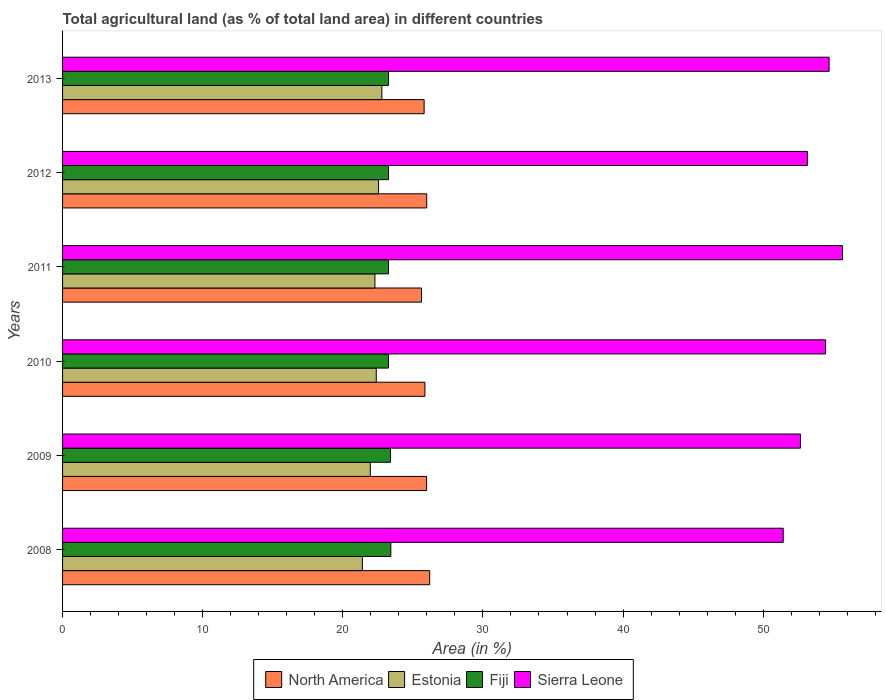How many groups of bars are there?
Offer a very short reply. 6. Are the number of bars per tick equal to the number of legend labels?
Offer a very short reply. Yes. Are the number of bars on each tick of the Y-axis equal?
Offer a very short reply. Yes. How many bars are there on the 4th tick from the top?
Offer a terse response. 4. What is the percentage of agricultural land in North America in 2008?
Give a very brief answer. 26.2. Across all years, what is the maximum percentage of agricultural land in Estonia?
Keep it short and to the point. 22.79. Across all years, what is the minimum percentage of agricultural land in Estonia?
Your answer should be compact. 21.4. In which year was the percentage of agricultural land in Estonia minimum?
Give a very brief answer. 2008. What is the total percentage of agricultural land in Fiji in the graph?
Your response must be concise. 139.88. What is the difference between the percentage of agricultural land in Fiji in 2008 and that in 2013?
Provide a succinct answer. 0.16. What is the difference between the percentage of agricultural land in Estonia in 2010 and the percentage of agricultural land in Fiji in 2011?
Keep it short and to the point. -0.87. What is the average percentage of agricultural land in Sierra Leone per year?
Make the answer very short. 53.68. In the year 2012, what is the difference between the percentage of agricultural land in Sierra Leone and percentage of agricultural land in Fiji?
Your answer should be compact. 29.89. What is the ratio of the percentage of agricultural land in Fiji in 2010 to that in 2012?
Your answer should be compact. 1. Is the percentage of agricultural land in Fiji in 2009 less than that in 2010?
Keep it short and to the point. No. Is the difference between the percentage of agricultural land in Sierra Leone in 2011 and 2013 greater than the difference between the percentage of agricultural land in Fiji in 2011 and 2013?
Your response must be concise. Yes. What is the difference between the highest and the second highest percentage of agricultural land in Sierra Leone?
Give a very brief answer. 0.96. What is the difference between the highest and the lowest percentage of agricultural land in North America?
Your answer should be compact. 0.58. What does the 3rd bar from the top in 2008 represents?
Your response must be concise. Estonia. What does the 4th bar from the bottom in 2013 represents?
Your answer should be very brief. Sierra Leone. Is it the case that in every year, the sum of the percentage of agricultural land in Estonia and percentage of agricultural land in Fiji is greater than the percentage of agricultural land in Sierra Leone?
Offer a very short reply. No. How many years are there in the graph?
Make the answer very short. 6. What is the difference between two consecutive major ticks on the X-axis?
Give a very brief answer. 10. Are the values on the major ticks of X-axis written in scientific E-notation?
Provide a short and direct response. No. Does the graph contain any zero values?
Ensure brevity in your answer.  No. Does the graph contain grids?
Offer a terse response. No. Where does the legend appear in the graph?
Offer a terse response. Bottom center. How many legend labels are there?
Give a very brief answer. 4. How are the legend labels stacked?
Offer a very short reply. Horizontal. What is the title of the graph?
Make the answer very short. Total agricultural land (as % of total land area) in different countries. What is the label or title of the X-axis?
Your response must be concise. Area (in %). What is the Area (in %) of North America in 2008?
Give a very brief answer. 26.2. What is the Area (in %) of Estonia in 2008?
Provide a succinct answer. 21.4. What is the Area (in %) in Fiji in 2008?
Keep it short and to the point. 23.43. What is the Area (in %) in Sierra Leone in 2008?
Your answer should be very brief. 51.43. What is the Area (in %) in North America in 2009?
Make the answer very short. 25.98. What is the Area (in %) in Estonia in 2009?
Your answer should be very brief. 21.96. What is the Area (in %) of Fiji in 2009?
Your response must be concise. 23.4. What is the Area (in %) of Sierra Leone in 2009?
Your answer should be very brief. 52.66. What is the Area (in %) in North America in 2010?
Your response must be concise. 25.86. What is the Area (in %) in Estonia in 2010?
Give a very brief answer. 22.39. What is the Area (in %) in Fiji in 2010?
Make the answer very short. 23.26. What is the Area (in %) in Sierra Leone in 2010?
Keep it short and to the point. 54.45. What is the Area (in %) of North America in 2011?
Give a very brief answer. 25.62. What is the Area (in %) in Estonia in 2011?
Make the answer very short. 22.29. What is the Area (in %) of Fiji in 2011?
Offer a very short reply. 23.26. What is the Area (in %) in Sierra Leone in 2011?
Your response must be concise. 55.66. What is the Area (in %) in North America in 2012?
Provide a succinct answer. 25.99. What is the Area (in %) of Estonia in 2012?
Your answer should be very brief. 22.55. What is the Area (in %) of Fiji in 2012?
Your response must be concise. 23.26. What is the Area (in %) in Sierra Leone in 2012?
Offer a very short reply. 53.15. What is the Area (in %) of North America in 2013?
Your answer should be very brief. 25.8. What is the Area (in %) of Estonia in 2013?
Make the answer very short. 22.79. What is the Area (in %) of Fiji in 2013?
Offer a terse response. 23.26. What is the Area (in %) in Sierra Leone in 2013?
Offer a terse response. 54.71. Across all years, what is the maximum Area (in %) in North America?
Make the answer very short. 26.2. Across all years, what is the maximum Area (in %) in Estonia?
Ensure brevity in your answer.  22.79. Across all years, what is the maximum Area (in %) of Fiji?
Make the answer very short. 23.43. Across all years, what is the maximum Area (in %) of Sierra Leone?
Your response must be concise. 55.66. Across all years, what is the minimum Area (in %) in North America?
Your answer should be very brief. 25.62. Across all years, what is the minimum Area (in %) in Estonia?
Offer a very short reply. 21.4. Across all years, what is the minimum Area (in %) in Fiji?
Your answer should be very brief. 23.26. Across all years, what is the minimum Area (in %) of Sierra Leone?
Provide a succinct answer. 51.43. What is the total Area (in %) in North America in the graph?
Offer a very short reply. 155.45. What is the total Area (in %) in Estonia in the graph?
Offer a terse response. 133.38. What is the total Area (in %) in Fiji in the graph?
Make the answer very short. 139.88. What is the total Area (in %) in Sierra Leone in the graph?
Offer a very short reply. 322.06. What is the difference between the Area (in %) of North America in 2008 and that in 2009?
Your response must be concise. 0.22. What is the difference between the Area (in %) in Estonia in 2008 and that in 2009?
Keep it short and to the point. -0.57. What is the difference between the Area (in %) of Fiji in 2008 and that in 2009?
Offer a terse response. 0.02. What is the difference between the Area (in %) of Sierra Leone in 2008 and that in 2009?
Your response must be concise. -1.23. What is the difference between the Area (in %) in North America in 2008 and that in 2010?
Offer a terse response. 0.34. What is the difference between the Area (in %) in Estonia in 2008 and that in 2010?
Your answer should be compact. -0.99. What is the difference between the Area (in %) of Fiji in 2008 and that in 2010?
Ensure brevity in your answer.  0.16. What is the difference between the Area (in %) of Sierra Leone in 2008 and that in 2010?
Give a very brief answer. -3.02. What is the difference between the Area (in %) of North America in 2008 and that in 2011?
Give a very brief answer. 0.58. What is the difference between the Area (in %) in Estonia in 2008 and that in 2011?
Ensure brevity in your answer.  -0.9. What is the difference between the Area (in %) of Fiji in 2008 and that in 2011?
Keep it short and to the point. 0.16. What is the difference between the Area (in %) of Sierra Leone in 2008 and that in 2011?
Give a very brief answer. -4.23. What is the difference between the Area (in %) in North America in 2008 and that in 2012?
Provide a short and direct response. 0.21. What is the difference between the Area (in %) of Estonia in 2008 and that in 2012?
Offer a very short reply. -1.16. What is the difference between the Area (in %) in Fiji in 2008 and that in 2012?
Give a very brief answer. 0.16. What is the difference between the Area (in %) in Sierra Leone in 2008 and that in 2012?
Provide a short and direct response. -1.72. What is the difference between the Area (in %) of North America in 2008 and that in 2013?
Provide a succinct answer. 0.4. What is the difference between the Area (in %) of Estonia in 2008 and that in 2013?
Offer a very short reply. -1.39. What is the difference between the Area (in %) of Fiji in 2008 and that in 2013?
Keep it short and to the point. 0.16. What is the difference between the Area (in %) in Sierra Leone in 2008 and that in 2013?
Provide a succinct answer. -3.28. What is the difference between the Area (in %) in North America in 2009 and that in 2010?
Your answer should be very brief. 0.12. What is the difference between the Area (in %) in Estonia in 2009 and that in 2010?
Give a very brief answer. -0.42. What is the difference between the Area (in %) of Fiji in 2009 and that in 2010?
Give a very brief answer. 0.14. What is the difference between the Area (in %) of Sierra Leone in 2009 and that in 2010?
Offer a terse response. -1.79. What is the difference between the Area (in %) in North America in 2009 and that in 2011?
Keep it short and to the point. 0.36. What is the difference between the Area (in %) in Estonia in 2009 and that in 2011?
Your answer should be very brief. -0.33. What is the difference between the Area (in %) in Fiji in 2009 and that in 2011?
Keep it short and to the point. 0.14. What is the difference between the Area (in %) in Sierra Leone in 2009 and that in 2011?
Offer a terse response. -3. What is the difference between the Area (in %) in North America in 2009 and that in 2012?
Provide a short and direct response. -0.01. What is the difference between the Area (in %) in Estonia in 2009 and that in 2012?
Ensure brevity in your answer.  -0.59. What is the difference between the Area (in %) in Fiji in 2009 and that in 2012?
Offer a very short reply. 0.14. What is the difference between the Area (in %) of Sierra Leone in 2009 and that in 2012?
Your answer should be very brief. -0.49. What is the difference between the Area (in %) of North America in 2009 and that in 2013?
Your response must be concise. 0.18. What is the difference between the Area (in %) in Estonia in 2009 and that in 2013?
Offer a terse response. -0.83. What is the difference between the Area (in %) of Fiji in 2009 and that in 2013?
Offer a very short reply. 0.14. What is the difference between the Area (in %) of Sierra Leone in 2009 and that in 2013?
Keep it short and to the point. -2.05. What is the difference between the Area (in %) in North America in 2010 and that in 2011?
Provide a short and direct response. 0.24. What is the difference between the Area (in %) in Estonia in 2010 and that in 2011?
Offer a terse response. 0.09. What is the difference between the Area (in %) of Fiji in 2010 and that in 2011?
Your response must be concise. 0. What is the difference between the Area (in %) of Sierra Leone in 2010 and that in 2011?
Provide a short and direct response. -1.21. What is the difference between the Area (in %) in North America in 2010 and that in 2012?
Offer a terse response. -0.13. What is the difference between the Area (in %) of Estonia in 2010 and that in 2012?
Offer a terse response. -0.17. What is the difference between the Area (in %) of Fiji in 2010 and that in 2012?
Give a very brief answer. 0. What is the difference between the Area (in %) of Sierra Leone in 2010 and that in 2012?
Provide a succinct answer. 1.3. What is the difference between the Area (in %) of North America in 2010 and that in 2013?
Offer a very short reply. 0.06. What is the difference between the Area (in %) in Estonia in 2010 and that in 2013?
Make the answer very short. -0.4. What is the difference between the Area (in %) of Fiji in 2010 and that in 2013?
Provide a succinct answer. 0. What is the difference between the Area (in %) in Sierra Leone in 2010 and that in 2013?
Your answer should be very brief. -0.25. What is the difference between the Area (in %) in North America in 2011 and that in 2012?
Make the answer very short. -0.37. What is the difference between the Area (in %) in Estonia in 2011 and that in 2012?
Your answer should be compact. -0.26. What is the difference between the Area (in %) of Fiji in 2011 and that in 2012?
Your answer should be very brief. 0. What is the difference between the Area (in %) of Sierra Leone in 2011 and that in 2012?
Your response must be concise. 2.51. What is the difference between the Area (in %) in North America in 2011 and that in 2013?
Give a very brief answer. -0.19. What is the difference between the Area (in %) of Estonia in 2011 and that in 2013?
Offer a terse response. -0.5. What is the difference between the Area (in %) of Sierra Leone in 2011 and that in 2013?
Your response must be concise. 0.96. What is the difference between the Area (in %) of North America in 2012 and that in 2013?
Ensure brevity in your answer.  0.18. What is the difference between the Area (in %) of Estonia in 2012 and that in 2013?
Provide a short and direct response. -0.24. What is the difference between the Area (in %) in Fiji in 2012 and that in 2013?
Give a very brief answer. 0. What is the difference between the Area (in %) of Sierra Leone in 2012 and that in 2013?
Give a very brief answer. -1.55. What is the difference between the Area (in %) of North America in 2008 and the Area (in %) of Estonia in 2009?
Your answer should be very brief. 4.24. What is the difference between the Area (in %) of North America in 2008 and the Area (in %) of Fiji in 2009?
Make the answer very short. 2.8. What is the difference between the Area (in %) in North America in 2008 and the Area (in %) in Sierra Leone in 2009?
Provide a short and direct response. -26.46. What is the difference between the Area (in %) in Estonia in 2008 and the Area (in %) in Fiji in 2009?
Your response must be concise. -2.01. What is the difference between the Area (in %) in Estonia in 2008 and the Area (in %) in Sierra Leone in 2009?
Offer a terse response. -31.26. What is the difference between the Area (in %) in Fiji in 2008 and the Area (in %) in Sierra Leone in 2009?
Your response must be concise. -29.23. What is the difference between the Area (in %) in North America in 2008 and the Area (in %) in Estonia in 2010?
Make the answer very short. 3.81. What is the difference between the Area (in %) of North America in 2008 and the Area (in %) of Fiji in 2010?
Keep it short and to the point. 2.94. What is the difference between the Area (in %) in North America in 2008 and the Area (in %) in Sierra Leone in 2010?
Keep it short and to the point. -28.25. What is the difference between the Area (in %) of Estonia in 2008 and the Area (in %) of Fiji in 2010?
Keep it short and to the point. -1.87. What is the difference between the Area (in %) in Estonia in 2008 and the Area (in %) in Sierra Leone in 2010?
Offer a very short reply. -33.06. What is the difference between the Area (in %) of Fiji in 2008 and the Area (in %) of Sierra Leone in 2010?
Ensure brevity in your answer.  -31.03. What is the difference between the Area (in %) of North America in 2008 and the Area (in %) of Estonia in 2011?
Keep it short and to the point. 3.91. What is the difference between the Area (in %) of North America in 2008 and the Area (in %) of Fiji in 2011?
Offer a terse response. 2.94. What is the difference between the Area (in %) of North America in 2008 and the Area (in %) of Sierra Leone in 2011?
Give a very brief answer. -29.46. What is the difference between the Area (in %) in Estonia in 2008 and the Area (in %) in Fiji in 2011?
Offer a very short reply. -1.87. What is the difference between the Area (in %) of Estonia in 2008 and the Area (in %) of Sierra Leone in 2011?
Your answer should be compact. -34.26. What is the difference between the Area (in %) of Fiji in 2008 and the Area (in %) of Sierra Leone in 2011?
Your response must be concise. -32.23. What is the difference between the Area (in %) of North America in 2008 and the Area (in %) of Estonia in 2012?
Your response must be concise. 3.65. What is the difference between the Area (in %) of North America in 2008 and the Area (in %) of Fiji in 2012?
Provide a succinct answer. 2.94. What is the difference between the Area (in %) of North America in 2008 and the Area (in %) of Sierra Leone in 2012?
Make the answer very short. -26.95. What is the difference between the Area (in %) of Estonia in 2008 and the Area (in %) of Fiji in 2012?
Provide a short and direct response. -1.87. What is the difference between the Area (in %) of Estonia in 2008 and the Area (in %) of Sierra Leone in 2012?
Your answer should be compact. -31.76. What is the difference between the Area (in %) of Fiji in 2008 and the Area (in %) of Sierra Leone in 2012?
Make the answer very short. -29.73. What is the difference between the Area (in %) of North America in 2008 and the Area (in %) of Estonia in 2013?
Your answer should be very brief. 3.41. What is the difference between the Area (in %) in North America in 2008 and the Area (in %) in Fiji in 2013?
Offer a very short reply. 2.94. What is the difference between the Area (in %) of North America in 2008 and the Area (in %) of Sierra Leone in 2013?
Make the answer very short. -28.5. What is the difference between the Area (in %) in Estonia in 2008 and the Area (in %) in Fiji in 2013?
Your response must be concise. -1.87. What is the difference between the Area (in %) of Estonia in 2008 and the Area (in %) of Sierra Leone in 2013?
Provide a short and direct response. -33.31. What is the difference between the Area (in %) of Fiji in 2008 and the Area (in %) of Sierra Leone in 2013?
Give a very brief answer. -31.28. What is the difference between the Area (in %) in North America in 2009 and the Area (in %) in Estonia in 2010?
Your answer should be compact. 3.59. What is the difference between the Area (in %) of North America in 2009 and the Area (in %) of Fiji in 2010?
Your response must be concise. 2.72. What is the difference between the Area (in %) in North America in 2009 and the Area (in %) in Sierra Leone in 2010?
Provide a short and direct response. -28.47. What is the difference between the Area (in %) in Estonia in 2009 and the Area (in %) in Fiji in 2010?
Offer a very short reply. -1.3. What is the difference between the Area (in %) in Estonia in 2009 and the Area (in %) in Sierra Leone in 2010?
Your response must be concise. -32.49. What is the difference between the Area (in %) in Fiji in 2009 and the Area (in %) in Sierra Leone in 2010?
Your answer should be compact. -31.05. What is the difference between the Area (in %) in North America in 2009 and the Area (in %) in Estonia in 2011?
Provide a succinct answer. 3.69. What is the difference between the Area (in %) in North America in 2009 and the Area (in %) in Fiji in 2011?
Make the answer very short. 2.72. What is the difference between the Area (in %) of North America in 2009 and the Area (in %) of Sierra Leone in 2011?
Provide a succinct answer. -29.68. What is the difference between the Area (in %) of Estonia in 2009 and the Area (in %) of Fiji in 2011?
Your response must be concise. -1.3. What is the difference between the Area (in %) in Estonia in 2009 and the Area (in %) in Sierra Leone in 2011?
Your answer should be very brief. -33.7. What is the difference between the Area (in %) in Fiji in 2009 and the Area (in %) in Sierra Leone in 2011?
Provide a succinct answer. -32.26. What is the difference between the Area (in %) of North America in 2009 and the Area (in %) of Estonia in 2012?
Your answer should be very brief. 3.43. What is the difference between the Area (in %) of North America in 2009 and the Area (in %) of Fiji in 2012?
Make the answer very short. 2.72. What is the difference between the Area (in %) of North America in 2009 and the Area (in %) of Sierra Leone in 2012?
Keep it short and to the point. -27.17. What is the difference between the Area (in %) of Estonia in 2009 and the Area (in %) of Fiji in 2012?
Provide a succinct answer. -1.3. What is the difference between the Area (in %) in Estonia in 2009 and the Area (in %) in Sierra Leone in 2012?
Keep it short and to the point. -31.19. What is the difference between the Area (in %) of Fiji in 2009 and the Area (in %) of Sierra Leone in 2012?
Ensure brevity in your answer.  -29.75. What is the difference between the Area (in %) of North America in 2009 and the Area (in %) of Estonia in 2013?
Ensure brevity in your answer.  3.19. What is the difference between the Area (in %) of North America in 2009 and the Area (in %) of Fiji in 2013?
Provide a succinct answer. 2.72. What is the difference between the Area (in %) of North America in 2009 and the Area (in %) of Sierra Leone in 2013?
Make the answer very short. -28.73. What is the difference between the Area (in %) in Estonia in 2009 and the Area (in %) in Fiji in 2013?
Provide a succinct answer. -1.3. What is the difference between the Area (in %) of Estonia in 2009 and the Area (in %) of Sierra Leone in 2013?
Provide a succinct answer. -32.74. What is the difference between the Area (in %) in Fiji in 2009 and the Area (in %) in Sierra Leone in 2013?
Provide a short and direct response. -31.3. What is the difference between the Area (in %) in North America in 2010 and the Area (in %) in Estonia in 2011?
Your response must be concise. 3.57. What is the difference between the Area (in %) of North America in 2010 and the Area (in %) of Fiji in 2011?
Your answer should be compact. 2.6. What is the difference between the Area (in %) of North America in 2010 and the Area (in %) of Sierra Leone in 2011?
Your answer should be compact. -29.8. What is the difference between the Area (in %) in Estonia in 2010 and the Area (in %) in Fiji in 2011?
Provide a succinct answer. -0.87. What is the difference between the Area (in %) in Estonia in 2010 and the Area (in %) in Sierra Leone in 2011?
Offer a very short reply. -33.27. What is the difference between the Area (in %) of Fiji in 2010 and the Area (in %) of Sierra Leone in 2011?
Ensure brevity in your answer.  -32.4. What is the difference between the Area (in %) in North America in 2010 and the Area (in %) in Estonia in 2012?
Your answer should be very brief. 3.31. What is the difference between the Area (in %) of North America in 2010 and the Area (in %) of Fiji in 2012?
Your answer should be very brief. 2.6. What is the difference between the Area (in %) of North America in 2010 and the Area (in %) of Sierra Leone in 2012?
Offer a terse response. -27.29. What is the difference between the Area (in %) in Estonia in 2010 and the Area (in %) in Fiji in 2012?
Make the answer very short. -0.87. What is the difference between the Area (in %) of Estonia in 2010 and the Area (in %) of Sierra Leone in 2012?
Provide a short and direct response. -30.77. What is the difference between the Area (in %) in Fiji in 2010 and the Area (in %) in Sierra Leone in 2012?
Provide a short and direct response. -29.89. What is the difference between the Area (in %) in North America in 2010 and the Area (in %) in Estonia in 2013?
Provide a succinct answer. 3.07. What is the difference between the Area (in %) in North America in 2010 and the Area (in %) in Fiji in 2013?
Give a very brief answer. 2.6. What is the difference between the Area (in %) in North America in 2010 and the Area (in %) in Sierra Leone in 2013?
Keep it short and to the point. -28.85. What is the difference between the Area (in %) in Estonia in 2010 and the Area (in %) in Fiji in 2013?
Your answer should be compact. -0.87. What is the difference between the Area (in %) in Estonia in 2010 and the Area (in %) in Sierra Leone in 2013?
Provide a succinct answer. -32.32. What is the difference between the Area (in %) of Fiji in 2010 and the Area (in %) of Sierra Leone in 2013?
Offer a terse response. -31.44. What is the difference between the Area (in %) of North America in 2011 and the Area (in %) of Estonia in 2012?
Provide a short and direct response. 3.06. What is the difference between the Area (in %) of North America in 2011 and the Area (in %) of Fiji in 2012?
Make the answer very short. 2.35. What is the difference between the Area (in %) in North America in 2011 and the Area (in %) in Sierra Leone in 2012?
Provide a succinct answer. -27.54. What is the difference between the Area (in %) in Estonia in 2011 and the Area (in %) in Fiji in 2012?
Offer a terse response. -0.97. What is the difference between the Area (in %) in Estonia in 2011 and the Area (in %) in Sierra Leone in 2012?
Give a very brief answer. -30.86. What is the difference between the Area (in %) in Fiji in 2011 and the Area (in %) in Sierra Leone in 2012?
Offer a very short reply. -29.89. What is the difference between the Area (in %) of North America in 2011 and the Area (in %) of Estonia in 2013?
Provide a short and direct response. 2.83. What is the difference between the Area (in %) in North America in 2011 and the Area (in %) in Fiji in 2013?
Provide a succinct answer. 2.35. What is the difference between the Area (in %) in North America in 2011 and the Area (in %) in Sierra Leone in 2013?
Give a very brief answer. -29.09. What is the difference between the Area (in %) of Estonia in 2011 and the Area (in %) of Fiji in 2013?
Offer a terse response. -0.97. What is the difference between the Area (in %) of Estonia in 2011 and the Area (in %) of Sierra Leone in 2013?
Offer a terse response. -32.41. What is the difference between the Area (in %) of Fiji in 2011 and the Area (in %) of Sierra Leone in 2013?
Make the answer very short. -31.44. What is the difference between the Area (in %) in North America in 2012 and the Area (in %) in Estonia in 2013?
Keep it short and to the point. 3.2. What is the difference between the Area (in %) in North America in 2012 and the Area (in %) in Fiji in 2013?
Offer a terse response. 2.73. What is the difference between the Area (in %) of North America in 2012 and the Area (in %) of Sierra Leone in 2013?
Your answer should be compact. -28.72. What is the difference between the Area (in %) of Estonia in 2012 and the Area (in %) of Fiji in 2013?
Give a very brief answer. -0.71. What is the difference between the Area (in %) in Estonia in 2012 and the Area (in %) in Sierra Leone in 2013?
Keep it short and to the point. -32.15. What is the difference between the Area (in %) in Fiji in 2012 and the Area (in %) in Sierra Leone in 2013?
Your answer should be very brief. -31.44. What is the average Area (in %) of North America per year?
Keep it short and to the point. 25.91. What is the average Area (in %) of Estonia per year?
Make the answer very short. 22.23. What is the average Area (in %) in Fiji per year?
Provide a succinct answer. 23.31. What is the average Area (in %) of Sierra Leone per year?
Your answer should be compact. 53.68. In the year 2008, what is the difference between the Area (in %) of North America and Area (in %) of Estonia?
Offer a very short reply. 4.8. In the year 2008, what is the difference between the Area (in %) of North America and Area (in %) of Fiji?
Make the answer very short. 2.77. In the year 2008, what is the difference between the Area (in %) of North America and Area (in %) of Sierra Leone?
Ensure brevity in your answer.  -25.23. In the year 2008, what is the difference between the Area (in %) of Estonia and Area (in %) of Fiji?
Make the answer very short. -2.03. In the year 2008, what is the difference between the Area (in %) in Estonia and Area (in %) in Sierra Leone?
Your response must be concise. -30.03. In the year 2008, what is the difference between the Area (in %) in Fiji and Area (in %) in Sierra Leone?
Your answer should be compact. -28. In the year 2009, what is the difference between the Area (in %) of North America and Area (in %) of Estonia?
Provide a short and direct response. 4.02. In the year 2009, what is the difference between the Area (in %) of North America and Area (in %) of Fiji?
Give a very brief answer. 2.58. In the year 2009, what is the difference between the Area (in %) of North America and Area (in %) of Sierra Leone?
Your answer should be compact. -26.68. In the year 2009, what is the difference between the Area (in %) in Estonia and Area (in %) in Fiji?
Offer a terse response. -1.44. In the year 2009, what is the difference between the Area (in %) in Estonia and Area (in %) in Sierra Leone?
Ensure brevity in your answer.  -30.7. In the year 2009, what is the difference between the Area (in %) of Fiji and Area (in %) of Sierra Leone?
Provide a short and direct response. -29.26. In the year 2010, what is the difference between the Area (in %) of North America and Area (in %) of Estonia?
Your response must be concise. 3.47. In the year 2010, what is the difference between the Area (in %) in North America and Area (in %) in Fiji?
Give a very brief answer. 2.6. In the year 2010, what is the difference between the Area (in %) of North America and Area (in %) of Sierra Leone?
Make the answer very short. -28.59. In the year 2010, what is the difference between the Area (in %) of Estonia and Area (in %) of Fiji?
Offer a terse response. -0.87. In the year 2010, what is the difference between the Area (in %) in Estonia and Area (in %) in Sierra Leone?
Give a very brief answer. -32.07. In the year 2010, what is the difference between the Area (in %) of Fiji and Area (in %) of Sierra Leone?
Offer a very short reply. -31.19. In the year 2011, what is the difference between the Area (in %) of North America and Area (in %) of Estonia?
Keep it short and to the point. 3.32. In the year 2011, what is the difference between the Area (in %) in North America and Area (in %) in Fiji?
Offer a terse response. 2.35. In the year 2011, what is the difference between the Area (in %) in North America and Area (in %) in Sierra Leone?
Offer a very short reply. -30.05. In the year 2011, what is the difference between the Area (in %) in Estonia and Area (in %) in Fiji?
Your answer should be very brief. -0.97. In the year 2011, what is the difference between the Area (in %) in Estonia and Area (in %) in Sierra Leone?
Offer a terse response. -33.37. In the year 2011, what is the difference between the Area (in %) in Fiji and Area (in %) in Sierra Leone?
Your answer should be very brief. -32.4. In the year 2012, what is the difference between the Area (in %) in North America and Area (in %) in Estonia?
Give a very brief answer. 3.44. In the year 2012, what is the difference between the Area (in %) in North America and Area (in %) in Fiji?
Provide a short and direct response. 2.73. In the year 2012, what is the difference between the Area (in %) in North America and Area (in %) in Sierra Leone?
Give a very brief answer. -27.17. In the year 2012, what is the difference between the Area (in %) of Estonia and Area (in %) of Fiji?
Offer a terse response. -0.71. In the year 2012, what is the difference between the Area (in %) in Estonia and Area (in %) in Sierra Leone?
Make the answer very short. -30.6. In the year 2012, what is the difference between the Area (in %) in Fiji and Area (in %) in Sierra Leone?
Give a very brief answer. -29.89. In the year 2013, what is the difference between the Area (in %) in North America and Area (in %) in Estonia?
Give a very brief answer. 3.02. In the year 2013, what is the difference between the Area (in %) in North America and Area (in %) in Fiji?
Your answer should be very brief. 2.54. In the year 2013, what is the difference between the Area (in %) in North America and Area (in %) in Sierra Leone?
Give a very brief answer. -28.9. In the year 2013, what is the difference between the Area (in %) of Estonia and Area (in %) of Fiji?
Offer a terse response. -0.47. In the year 2013, what is the difference between the Area (in %) in Estonia and Area (in %) in Sierra Leone?
Your answer should be very brief. -31.92. In the year 2013, what is the difference between the Area (in %) of Fiji and Area (in %) of Sierra Leone?
Your response must be concise. -31.44. What is the ratio of the Area (in %) in North America in 2008 to that in 2009?
Give a very brief answer. 1.01. What is the ratio of the Area (in %) in Estonia in 2008 to that in 2009?
Provide a succinct answer. 0.97. What is the ratio of the Area (in %) of Fiji in 2008 to that in 2009?
Provide a succinct answer. 1. What is the ratio of the Area (in %) of Sierra Leone in 2008 to that in 2009?
Provide a succinct answer. 0.98. What is the ratio of the Area (in %) in North America in 2008 to that in 2010?
Provide a short and direct response. 1.01. What is the ratio of the Area (in %) of Estonia in 2008 to that in 2010?
Keep it short and to the point. 0.96. What is the ratio of the Area (in %) in Fiji in 2008 to that in 2010?
Provide a succinct answer. 1.01. What is the ratio of the Area (in %) in Sierra Leone in 2008 to that in 2010?
Your answer should be very brief. 0.94. What is the ratio of the Area (in %) of North America in 2008 to that in 2011?
Your answer should be very brief. 1.02. What is the ratio of the Area (in %) of Estonia in 2008 to that in 2011?
Give a very brief answer. 0.96. What is the ratio of the Area (in %) of Fiji in 2008 to that in 2011?
Offer a terse response. 1.01. What is the ratio of the Area (in %) in Sierra Leone in 2008 to that in 2011?
Provide a succinct answer. 0.92. What is the ratio of the Area (in %) in North America in 2008 to that in 2012?
Give a very brief answer. 1.01. What is the ratio of the Area (in %) of Estonia in 2008 to that in 2012?
Your response must be concise. 0.95. What is the ratio of the Area (in %) of Fiji in 2008 to that in 2012?
Provide a short and direct response. 1.01. What is the ratio of the Area (in %) in Sierra Leone in 2008 to that in 2012?
Your response must be concise. 0.97. What is the ratio of the Area (in %) of North America in 2008 to that in 2013?
Offer a terse response. 1.02. What is the ratio of the Area (in %) in Estonia in 2008 to that in 2013?
Your answer should be very brief. 0.94. What is the ratio of the Area (in %) in Fiji in 2008 to that in 2013?
Provide a succinct answer. 1.01. What is the ratio of the Area (in %) of Sierra Leone in 2008 to that in 2013?
Provide a succinct answer. 0.94. What is the ratio of the Area (in %) of North America in 2009 to that in 2010?
Give a very brief answer. 1. What is the ratio of the Area (in %) in Estonia in 2009 to that in 2010?
Provide a short and direct response. 0.98. What is the ratio of the Area (in %) of Sierra Leone in 2009 to that in 2010?
Your response must be concise. 0.97. What is the ratio of the Area (in %) of North America in 2009 to that in 2011?
Provide a succinct answer. 1.01. What is the ratio of the Area (in %) of Estonia in 2009 to that in 2011?
Your answer should be very brief. 0.99. What is the ratio of the Area (in %) in Sierra Leone in 2009 to that in 2011?
Provide a succinct answer. 0.95. What is the ratio of the Area (in %) in Estonia in 2009 to that in 2012?
Provide a succinct answer. 0.97. What is the ratio of the Area (in %) of Fiji in 2009 to that in 2012?
Offer a very short reply. 1.01. What is the ratio of the Area (in %) of North America in 2009 to that in 2013?
Ensure brevity in your answer.  1.01. What is the ratio of the Area (in %) in Estonia in 2009 to that in 2013?
Offer a very short reply. 0.96. What is the ratio of the Area (in %) of Fiji in 2009 to that in 2013?
Make the answer very short. 1.01. What is the ratio of the Area (in %) in Sierra Leone in 2009 to that in 2013?
Keep it short and to the point. 0.96. What is the ratio of the Area (in %) of North America in 2010 to that in 2011?
Make the answer very short. 1.01. What is the ratio of the Area (in %) of Estonia in 2010 to that in 2011?
Your answer should be compact. 1. What is the ratio of the Area (in %) in Fiji in 2010 to that in 2011?
Ensure brevity in your answer.  1. What is the ratio of the Area (in %) of Sierra Leone in 2010 to that in 2011?
Your answer should be very brief. 0.98. What is the ratio of the Area (in %) of Fiji in 2010 to that in 2012?
Keep it short and to the point. 1. What is the ratio of the Area (in %) in Sierra Leone in 2010 to that in 2012?
Offer a terse response. 1.02. What is the ratio of the Area (in %) in Estonia in 2010 to that in 2013?
Provide a succinct answer. 0.98. What is the ratio of the Area (in %) in North America in 2011 to that in 2012?
Offer a terse response. 0.99. What is the ratio of the Area (in %) in Sierra Leone in 2011 to that in 2012?
Give a very brief answer. 1.05. What is the ratio of the Area (in %) of North America in 2011 to that in 2013?
Your answer should be compact. 0.99. What is the ratio of the Area (in %) in Estonia in 2011 to that in 2013?
Offer a very short reply. 0.98. What is the ratio of the Area (in %) in Sierra Leone in 2011 to that in 2013?
Your answer should be compact. 1.02. What is the ratio of the Area (in %) of North America in 2012 to that in 2013?
Offer a terse response. 1.01. What is the ratio of the Area (in %) in Fiji in 2012 to that in 2013?
Offer a terse response. 1. What is the ratio of the Area (in %) in Sierra Leone in 2012 to that in 2013?
Offer a terse response. 0.97. What is the difference between the highest and the second highest Area (in %) in North America?
Offer a very short reply. 0.21. What is the difference between the highest and the second highest Area (in %) of Estonia?
Make the answer very short. 0.24. What is the difference between the highest and the second highest Area (in %) of Fiji?
Keep it short and to the point. 0.02. What is the difference between the highest and the second highest Area (in %) of Sierra Leone?
Your answer should be very brief. 0.96. What is the difference between the highest and the lowest Area (in %) of North America?
Make the answer very short. 0.58. What is the difference between the highest and the lowest Area (in %) of Estonia?
Keep it short and to the point. 1.39. What is the difference between the highest and the lowest Area (in %) in Fiji?
Provide a short and direct response. 0.16. What is the difference between the highest and the lowest Area (in %) of Sierra Leone?
Your response must be concise. 4.23. 